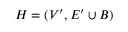Convert formula to latex. <formula><loc_0><loc_0><loc_500><loc_500>H = ( V ^ { \prime } , E ^ { \prime } \cup B )</formula> 